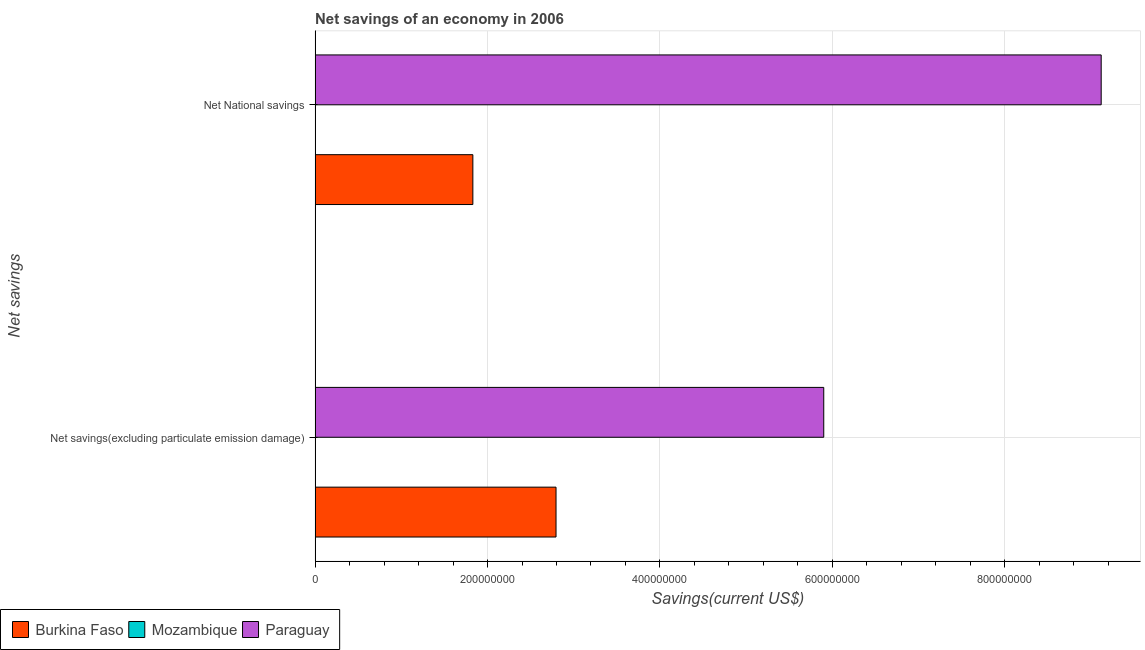How many different coloured bars are there?
Give a very brief answer. 2. How many groups of bars are there?
Ensure brevity in your answer.  2. How many bars are there on the 2nd tick from the top?
Keep it short and to the point. 2. What is the label of the 1st group of bars from the top?
Offer a very short reply. Net National savings. What is the net savings(excluding particulate emission damage) in Paraguay?
Offer a terse response. 5.90e+08. Across all countries, what is the maximum net savings(excluding particulate emission damage)?
Your answer should be very brief. 5.90e+08. Across all countries, what is the minimum net savings(excluding particulate emission damage)?
Ensure brevity in your answer.  0. In which country was the net savings(excluding particulate emission damage) maximum?
Give a very brief answer. Paraguay. What is the total net national savings in the graph?
Ensure brevity in your answer.  1.09e+09. What is the difference between the net savings(excluding particulate emission damage) in Paraguay and that in Burkina Faso?
Offer a terse response. 3.11e+08. What is the difference between the net savings(excluding particulate emission damage) in Burkina Faso and the net national savings in Mozambique?
Provide a short and direct response. 2.79e+08. What is the average net savings(excluding particulate emission damage) per country?
Provide a succinct answer. 2.90e+08. What is the difference between the net savings(excluding particulate emission damage) and net national savings in Burkina Faso?
Ensure brevity in your answer.  9.65e+07. In how many countries, is the net national savings greater than 520000000 US$?
Offer a terse response. 1. What is the ratio of the net national savings in Burkina Faso to that in Paraguay?
Ensure brevity in your answer.  0.2. How many bars are there?
Your answer should be very brief. 4. How many countries are there in the graph?
Ensure brevity in your answer.  3. Where does the legend appear in the graph?
Ensure brevity in your answer.  Bottom left. What is the title of the graph?
Your answer should be compact. Net savings of an economy in 2006. Does "Samoa" appear as one of the legend labels in the graph?
Your response must be concise. No. What is the label or title of the X-axis?
Keep it short and to the point. Savings(current US$). What is the label or title of the Y-axis?
Keep it short and to the point. Net savings. What is the Savings(current US$) in Burkina Faso in Net savings(excluding particulate emission damage)?
Offer a very short reply. 2.79e+08. What is the Savings(current US$) in Paraguay in Net savings(excluding particulate emission damage)?
Offer a terse response. 5.90e+08. What is the Savings(current US$) of Burkina Faso in Net National savings?
Provide a succinct answer. 1.83e+08. What is the Savings(current US$) in Paraguay in Net National savings?
Provide a short and direct response. 9.12e+08. Across all Net savings, what is the maximum Savings(current US$) of Burkina Faso?
Provide a succinct answer. 2.79e+08. Across all Net savings, what is the maximum Savings(current US$) of Paraguay?
Provide a short and direct response. 9.12e+08. Across all Net savings, what is the minimum Savings(current US$) in Burkina Faso?
Your answer should be compact. 1.83e+08. Across all Net savings, what is the minimum Savings(current US$) of Paraguay?
Keep it short and to the point. 5.90e+08. What is the total Savings(current US$) of Burkina Faso in the graph?
Ensure brevity in your answer.  4.62e+08. What is the total Savings(current US$) in Mozambique in the graph?
Your answer should be very brief. 0. What is the total Savings(current US$) of Paraguay in the graph?
Provide a succinct answer. 1.50e+09. What is the difference between the Savings(current US$) in Burkina Faso in Net savings(excluding particulate emission damage) and that in Net National savings?
Your answer should be compact. 9.65e+07. What is the difference between the Savings(current US$) of Paraguay in Net savings(excluding particulate emission damage) and that in Net National savings?
Your response must be concise. -3.22e+08. What is the difference between the Savings(current US$) in Burkina Faso in Net savings(excluding particulate emission damage) and the Savings(current US$) in Paraguay in Net National savings?
Give a very brief answer. -6.32e+08. What is the average Savings(current US$) in Burkina Faso per Net savings?
Provide a succinct answer. 2.31e+08. What is the average Savings(current US$) in Paraguay per Net savings?
Your response must be concise. 7.51e+08. What is the difference between the Savings(current US$) of Burkina Faso and Savings(current US$) of Paraguay in Net savings(excluding particulate emission damage)?
Ensure brevity in your answer.  -3.11e+08. What is the difference between the Savings(current US$) in Burkina Faso and Savings(current US$) in Paraguay in Net National savings?
Offer a terse response. -7.29e+08. What is the ratio of the Savings(current US$) in Burkina Faso in Net savings(excluding particulate emission damage) to that in Net National savings?
Your answer should be compact. 1.53. What is the ratio of the Savings(current US$) in Paraguay in Net savings(excluding particulate emission damage) to that in Net National savings?
Make the answer very short. 0.65. What is the difference between the highest and the second highest Savings(current US$) in Burkina Faso?
Offer a very short reply. 9.65e+07. What is the difference between the highest and the second highest Savings(current US$) of Paraguay?
Offer a very short reply. 3.22e+08. What is the difference between the highest and the lowest Savings(current US$) of Burkina Faso?
Keep it short and to the point. 9.65e+07. What is the difference between the highest and the lowest Savings(current US$) of Paraguay?
Offer a terse response. 3.22e+08. 